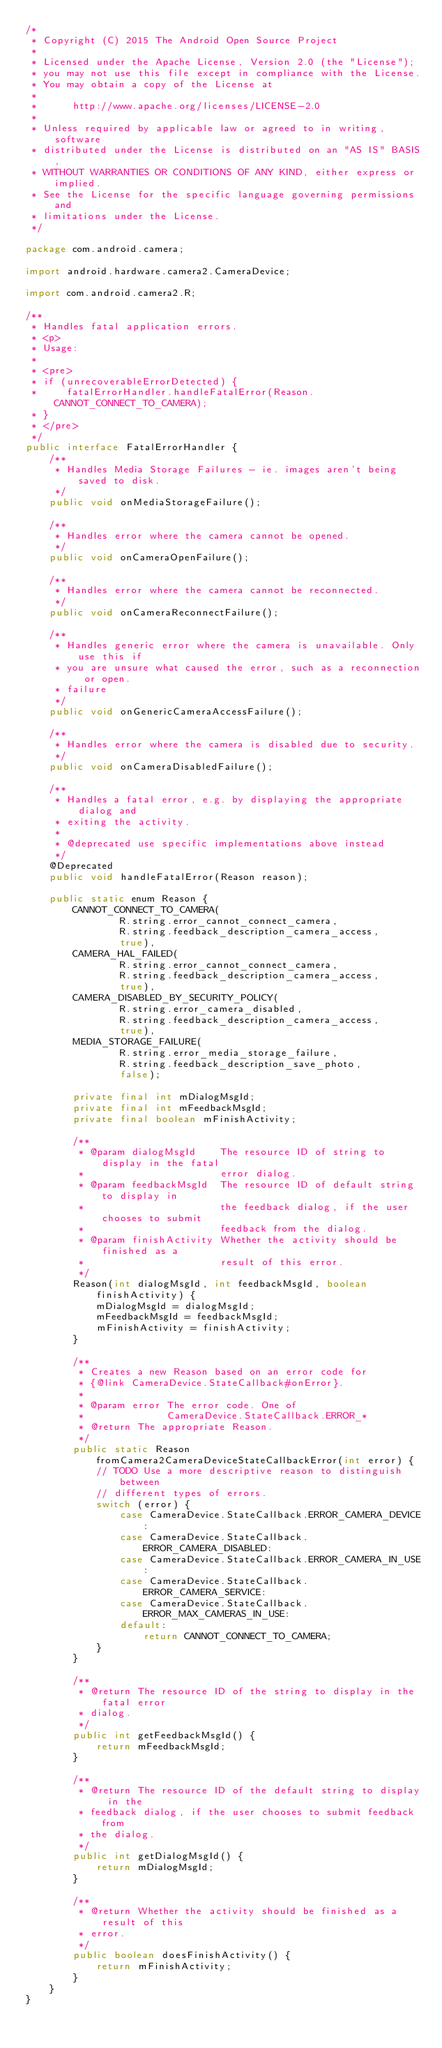<code> <loc_0><loc_0><loc_500><loc_500><_Java_>/*
 * Copyright (C) 2015 The Android Open Source Project
 *
 * Licensed under the Apache License, Version 2.0 (the "License");
 * you may not use this file except in compliance with the License.
 * You may obtain a copy of the License at
 *
 *      http://www.apache.org/licenses/LICENSE-2.0
 *
 * Unless required by applicable law or agreed to in writing, software
 * distributed under the License is distributed on an "AS IS" BASIS,
 * WITHOUT WARRANTIES OR CONDITIONS OF ANY KIND, either express or implied.
 * See the License for the specific language governing permissions and
 * limitations under the License.
 */

package com.android.camera;

import android.hardware.camera2.CameraDevice;

import com.android.camera2.R;

/**
 * Handles fatal application errors.
 * <p>
 * Usage:
 *
 * <pre>
 * if (unrecoverableErrorDetected) {
 *     fatalErrorHandler.handleFatalError(Reason.CANNOT_CONNECT_TO_CAMERA);
 * }
 * </pre>
 */
public interface FatalErrorHandler {
    /**
     * Handles Media Storage Failures - ie. images aren't being saved to disk.
     */
    public void onMediaStorageFailure();

    /**
     * Handles error where the camera cannot be opened.
     */
    public void onCameraOpenFailure();

    /**
     * Handles error where the camera cannot be reconnected.
     */
    public void onCameraReconnectFailure();

    /**
     * Handles generic error where the camera is unavailable. Only use this if
     * you are unsure what caused the error, such as a reconnection or open.
     * failure
     */
    public void onGenericCameraAccessFailure();

    /**
     * Handles error where the camera is disabled due to security.
     */
    public void onCameraDisabledFailure();

    /**
     * Handles a fatal error, e.g. by displaying the appropriate dialog and
     * exiting the activity.
     *
     * @deprecated use specific implementations above instead
     */
    @Deprecated
    public void handleFatalError(Reason reason);

    public static enum Reason {
        CANNOT_CONNECT_TO_CAMERA(
                R.string.error_cannot_connect_camera,
                R.string.feedback_description_camera_access,
                true),
        CAMERA_HAL_FAILED(
                R.string.error_cannot_connect_camera,
                R.string.feedback_description_camera_access,
                true),
        CAMERA_DISABLED_BY_SECURITY_POLICY(
                R.string.error_camera_disabled,
                R.string.feedback_description_camera_access,
                true),
        MEDIA_STORAGE_FAILURE(
                R.string.error_media_storage_failure,
                R.string.feedback_description_save_photo,
                false);

        private final int mDialogMsgId;
        private final int mFeedbackMsgId;
        private final boolean mFinishActivity;

        /**
         * @param dialogMsgId    The resource ID of string to display in the fatal
         *                       error dialog.
         * @param feedbackMsgId  The resource ID of default string to display in
         *                       the feedback dialog, if the user chooses to submit
         *                       feedback from the dialog.
         * @param finishActivity Whether the activity should be finished as a
         *                       result of this error.
         */
        Reason(int dialogMsgId, int feedbackMsgId, boolean finishActivity) {
            mDialogMsgId = dialogMsgId;
            mFeedbackMsgId = feedbackMsgId;
            mFinishActivity = finishActivity;
        }

        /**
         * Creates a new Reason based on an error code for
         * {@link CameraDevice.StateCallback#onError}.
         *
         * @param error The error code. One of
         *              CameraDevice.StateCallback.ERROR_*
         * @return The appropriate Reason.
         */
        public static Reason fromCamera2CameraDeviceStateCallbackError(int error) {
            // TODO Use a more descriptive reason to distinguish between
            // different types of errors.
            switch (error) {
                case CameraDevice.StateCallback.ERROR_CAMERA_DEVICE:
                case CameraDevice.StateCallback.ERROR_CAMERA_DISABLED:
                case CameraDevice.StateCallback.ERROR_CAMERA_IN_USE:
                case CameraDevice.StateCallback.ERROR_CAMERA_SERVICE:
                case CameraDevice.StateCallback.ERROR_MAX_CAMERAS_IN_USE:
                default:
                    return CANNOT_CONNECT_TO_CAMERA;
            }
        }

        /**
         * @return The resource ID of the string to display in the fatal error
         * dialog.
         */
        public int getFeedbackMsgId() {
            return mFeedbackMsgId;
        }

        /**
         * @return The resource ID of the default string to display in the
         * feedback dialog, if the user chooses to submit feedback from
         * the dialog.
         */
        public int getDialogMsgId() {
            return mDialogMsgId;
        }

        /**
         * @return Whether the activity should be finished as a result of this
         * error.
         */
        public boolean doesFinishActivity() {
            return mFinishActivity;
        }
    }
}
</code> 